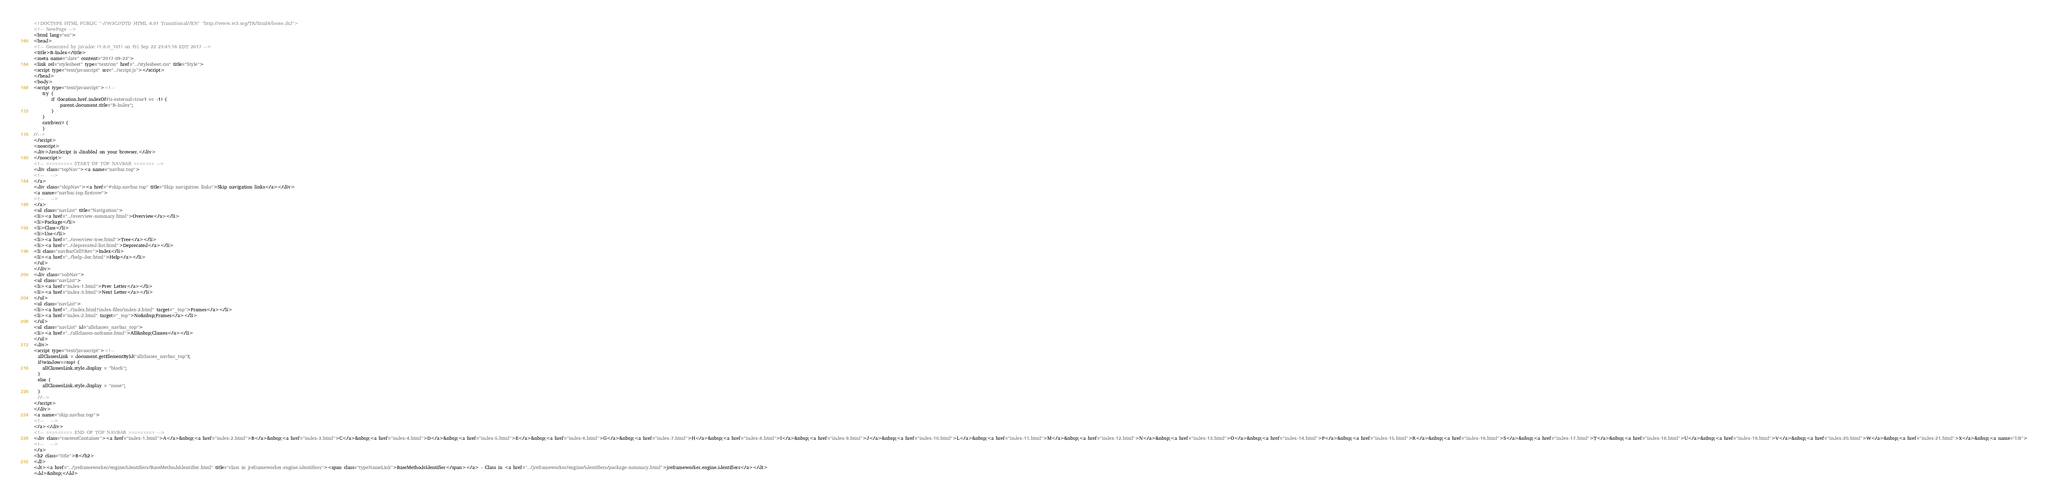Convert code to text. <code><loc_0><loc_0><loc_500><loc_500><_HTML_><!DOCTYPE HTML PUBLIC "-//W3C//DTD HTML 4.01 Transitional//EN" "http://www.w3.org/TR/html4/loose.dtd">
<!-- NewPage -->
<html lang="en">
<head>
<!-- Generated by javadoc (1.8.0_101) on Fri Sep 22 23:41:16 EDT 2017 -->
<title>B-Index</title>
<meta name="date" content="2017-09-22">
<link rel="stylesheet" type="text/css" href="../stylesheet.css" title="Style">
<script type="text/javascript" src="../script.js"></script>
</head>
<body>
<script type="text/javascript"><!--
    try {
        if (location.href.indexOf('is-external=true') == -1) {
            parent.document.title="B-Index";
        }
    }
    catch(err) {
    }
//-->
</script>
<noscript>
<div>JavaScript is disabled on your browser.</div>
</noscript>
<!-- ========= START OF TOP NAVBAR ======= -->
<div class="topNav"><a name="navbar.top">
<!--   -->
</a>
<div class="skipNav"><a href="#skip.navbar.top" title="Skip navigation links">Skip navigation links</a></div>
<a name="navbar.top.firstrow">
<!--   -->
</a>
<ul class="navList" title="Navigation">
<li><a href="../overview-summary.html">Overview</a></li>
<li>Package</li>
<li>Class</li>
<li>Use</li>
<li><a href="../overview-tree.html">Tree</a></li>
<li><a href="../deprecated-list.html">Deprecated</a></li>
<li class="navBarCell1Rev">Index</li>
<li><a href="../help-doc.html">Help</a></li>
</ul>
</div>
<div class="subNav">
<ul class="navList">
<li><a href="index-1.html">Prev Letter</a></li>
<li><a href="index-3.html">Next Letter</a></li>
</ul>
<ul class="navList">
<li><a href="../index.html?index-files/index-2.html" target="_top">Frames</a></li>
<li><a href="index-2.html" target="_top">No&nbsp;Frames</a></li>
</ul>
<ul class="navList" id="allclasses_navbar_top">
<li><a href="../allclasses-noframe.html">All&nbsp;Classes</a></li>
</ul>
<div>
<script type="text/javascript"><!--
  allClassesLink = document.getElementById("allclasses_navbar_top");
  if(window==top) {
    allClassesLink.style.display = "block";
  }
  else {
    allClassesLink.style.display = "none";
  }
  //-->
</script>
</div>
<a name="skip.navbar.top">
<!--   -->
</a></div>
<!-- ========= END OF TOP NAVBAR ========= -->
<div class="contentContainer"><a href="index-1.html">A</a>&nbsp;<a href="index-2.html">B</a>&nbsp;<a href="index-3.html">C</a>&nbsp;<a href="index-4.html">D</a>&nbsp;<a href="index-5.html">E</a>&nbsp;<a href="index-6.html">G</a>&nbsp;<a href="index-7.html">H</a>&nbsp;<a href="index-8.html">I</a>&nbsp;<a href="index-9.html">J</a>&nbsp;<a href="index-10.html">L</a>&nbsp;<a href="index-11.html">M</a>&nbsp;<a href="index-12.html">N</a>&nbsp;<a href="index-13.html">O</a>&nbsp;<a href="index-14.html">P</a>&nbsp;<a href="index-15.html">R</a>&nbsp;<a href="index-16.html">S</a>&nbsp;<a href="index-17.html">T</a>&nbsp;<a href="index-18.html">U</a>&nbsp;<a href="index-19.html">V</a>&nbsp;<a href="index-20.html">W</a>&nbsp;<a href="index-21.html">X</a>&nbsp;<a name="I:B">
<!--   -->
</a>
<h2 class="title">B</h2>
<dl>
<dt><a href="../jreframeworker/engine/identifiers/BaseMethodsIdentifier.html" title="class in jreframeworker.engine.identifiers"><span class="typeNameLink">BaseMethodsIdentifier</span></a> - Class in <a href="../jreframeworker/engine/identifiers/package-summary.html">jreframeworker.engine.identifiers</a></dt>
<dd>&nbsp;</dd></code> 